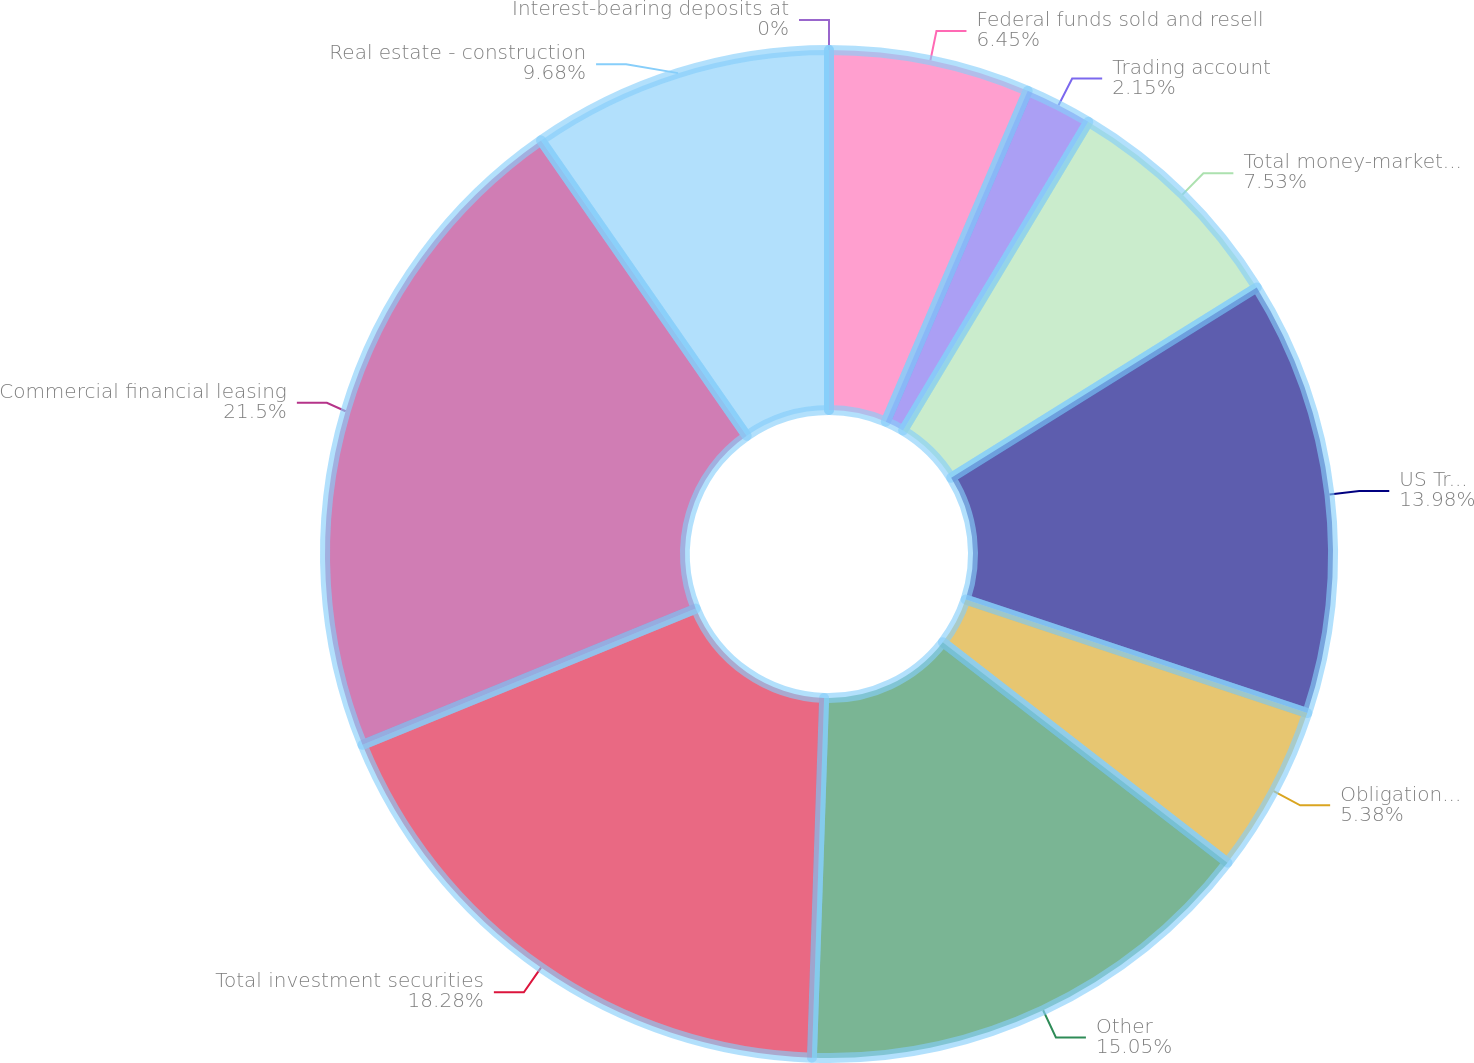Convert chart. <chart><loc_0><loc_0><loc_500><loc_500><pie_chart><fcel>Interest-bearing deposits at<fcel>Federal funds sold and resell<fcel>Trading account<fcel>Total money-market assets<fcel>US Treasury and federal<fcel>Obligations of states and<fcel>Other<fcel>Total investment securities<fcel>Commercial financial leasing<fcel>Real estate - construction<nl><fcel>0.0%<fcel>6.45%<fcel>2.15%<fcel>7.53%<fcel>13.98%<fcel>5.38%<fcel>15.05%<fcel>18.28%<fcel>21.5%<fcel>9.68%<nl></chart> 